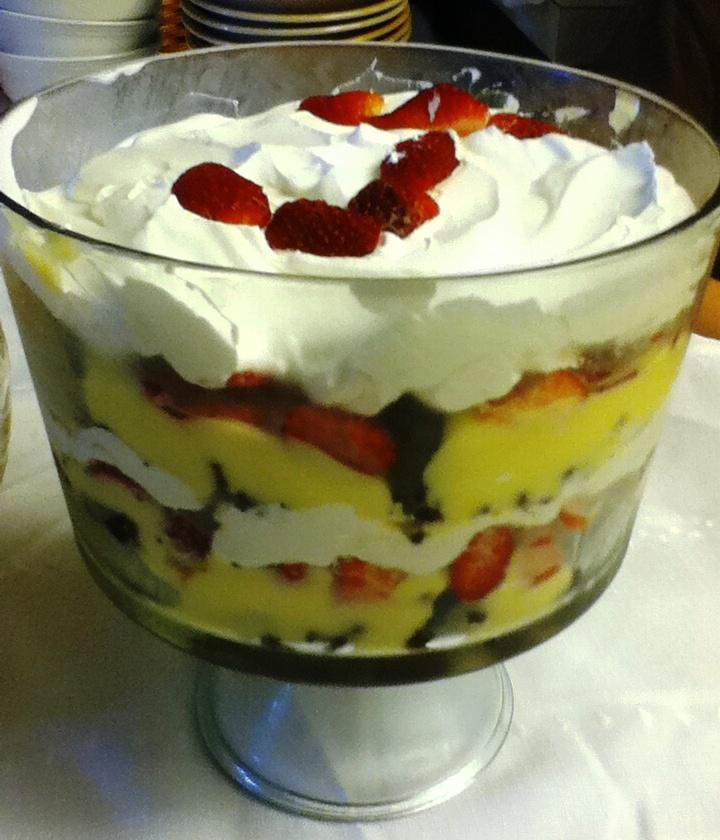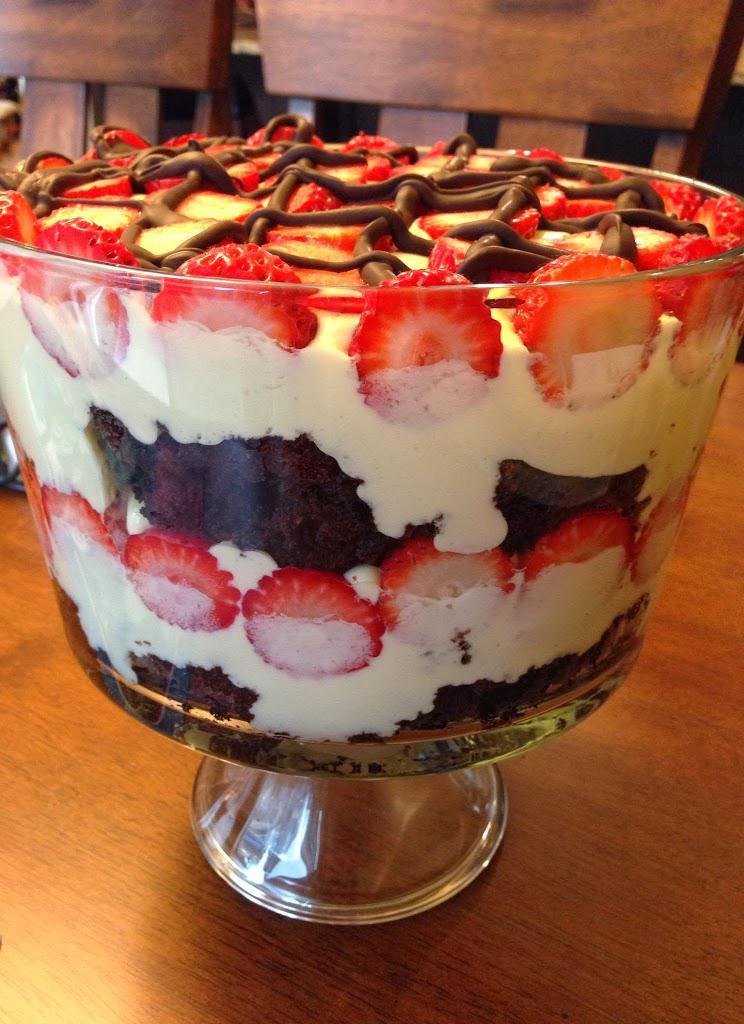The first image is the image on the left, the second image is the image on the right. Considering the images on both sides, is "Two large fancy layered desserts are in footed bowls." valid? Answer yes or no. Yes. The first image is the image on the left, the second image is the image on the right. Given the left and right images, does the statement "There is caramel drizzled atop the desert in the image on the left." hold true? Answer yes or no. No. 